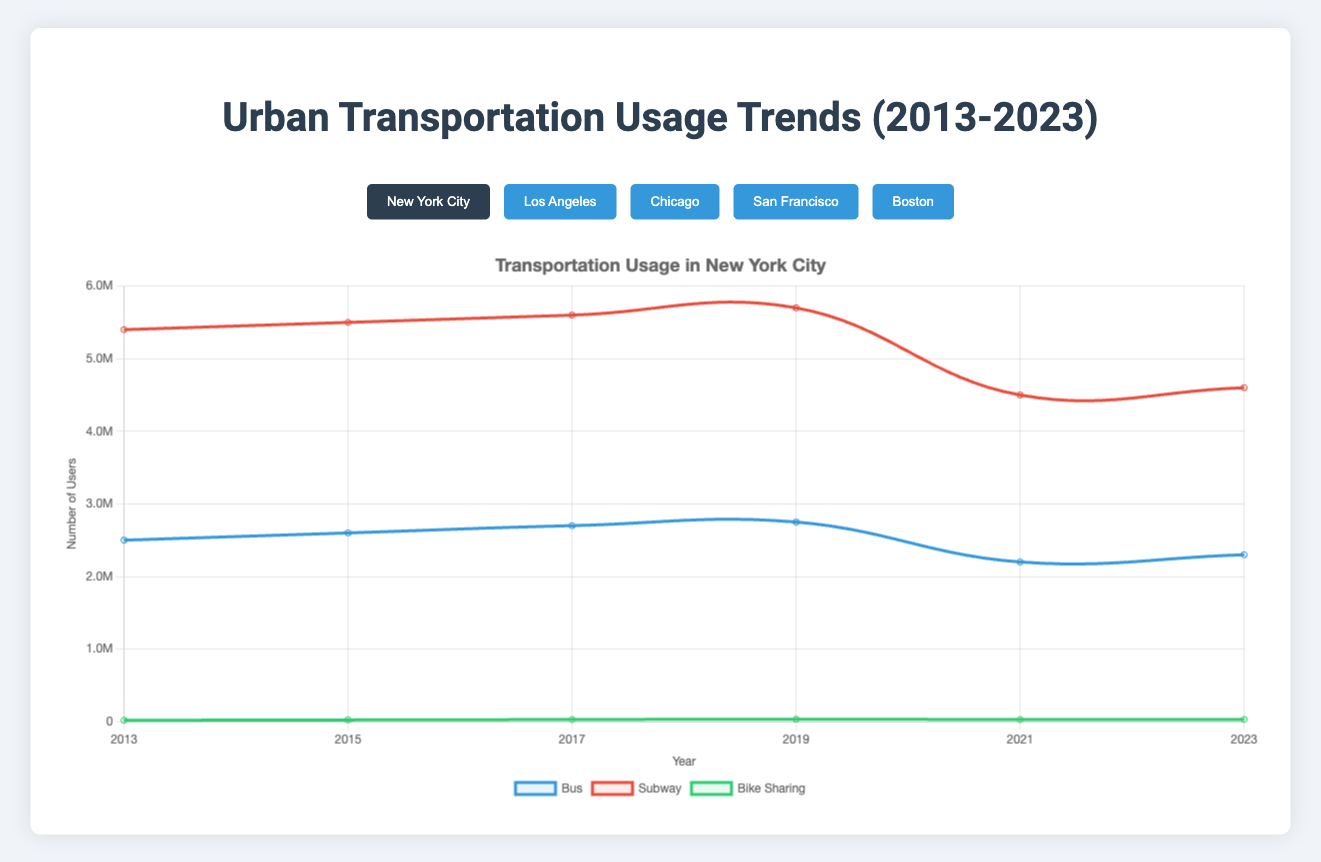What year did New York City have the highest subway usage? By observing the curve for subway usage, the highest value appears in 2019 at 5.7 million users.
Answer: 2019 Which city had the highest bike-sharing usage in 2023? By comparing the green curves for bike-sharing across all cities in 2023, New York City had the highest bike-sharing usage with 32,000 users.
Answer: New York City How did bus usage in Chicago change from 2019 to 2021? From the chart, bus usage in Chicago decreased from 1,450,000 in 2019 to 1,100,000 in 2021, a difference of 350,000.
Answer: Decreased by 350,000 In 2021, which mode of transportation had the sharpest decline in New York City compared to 2019? Comparing the slopes from 2019 to 2021, subway usage in New York City shows the sharpest decline from 5,700,000 to 4,500,000, a difference of 1,200,000.
Answer: Subway What's the overall trend for bike-sharing usage in Boston from 2013 to 2023? Observing the green curve for bike-sharing in Boston, there is an overall upward trend from 8,000 users in 2013 to 17,000 users in 2023.
Answer: Upward trend Compare the subway usage between Chicago and San Francisco in 2023. Which one is higher? By looking at the red curves, Chicago had 420,000 subway users, while San Francisco had 360,000 in 2023. Therefore, Chicago's subway usage was higher.
Answer: Chicago What was the total bus usage across all five cities in 2017? Summing the bus usage for all cities in 2017: NYC (2,700,000) + LA (1,200,000) + Chicago (1,400,000) + SF (850,000) + Boston (620,000) = 6,770,000.
Answer: 6,770,000 What mode of transportation experienced the most consistent growth in New York City from 2013 to 2019? By tracking each curve for New York City from 2013 to 2019, bike-sharing shows consistent growth without any decline, increasing from 20,000 to 35,000 users.
Answer: Bike-sharing What's the largest decline in any mode of transportation for Los Angeles between two consecutive years? For Los Angeles bike-sharing between 2021 and 2023, the usage dropped from 21,000 to 23,000, marking the largest decline of 4,000 users.
Answer: Bike-sharing What is the difference in subway usage between 2015 and 2023 in Boston? The subway usage in Boston was 820,000 in 2015 and 670,000 in 2023. The difference is 820,000 - 670,000 = 150,000 users.
Answer: 150,000 